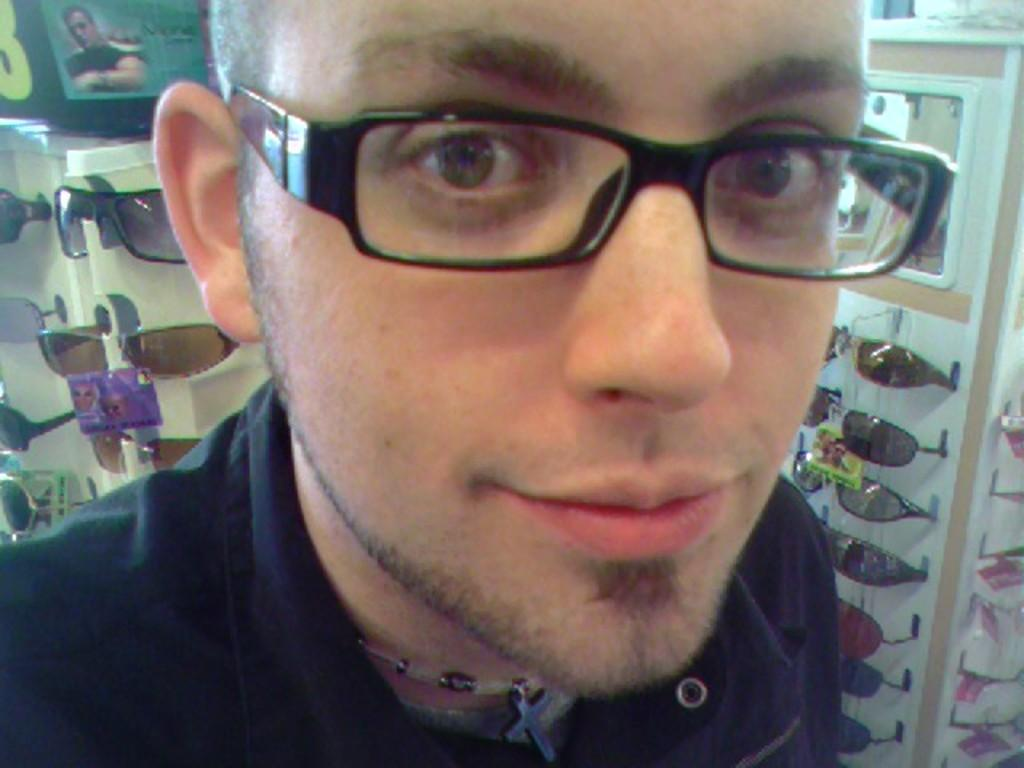What is the main subject of the image? There is a man standing in the image. What can be seen on the man's face? The man is wearing spectacles. What type of eyewear can be seen in the background of the image? There are sunglasses visible in the background of the image. What type of hammer is the man holding in the image? There is no hammer present in the image; the man is only wearing spectacles and standing. 